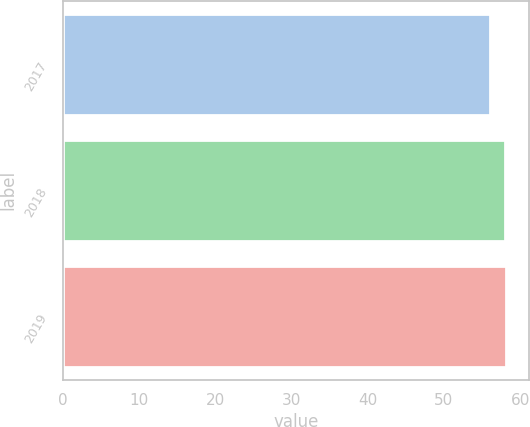Convert chart. <chart><loc_0><loc_0><loc_500><loc_500><bar_chart><fcel>2017<fcel>2018<fcel>2019<nl><fcel>56<fcel>58<fcel>58.2<nl></chart> 